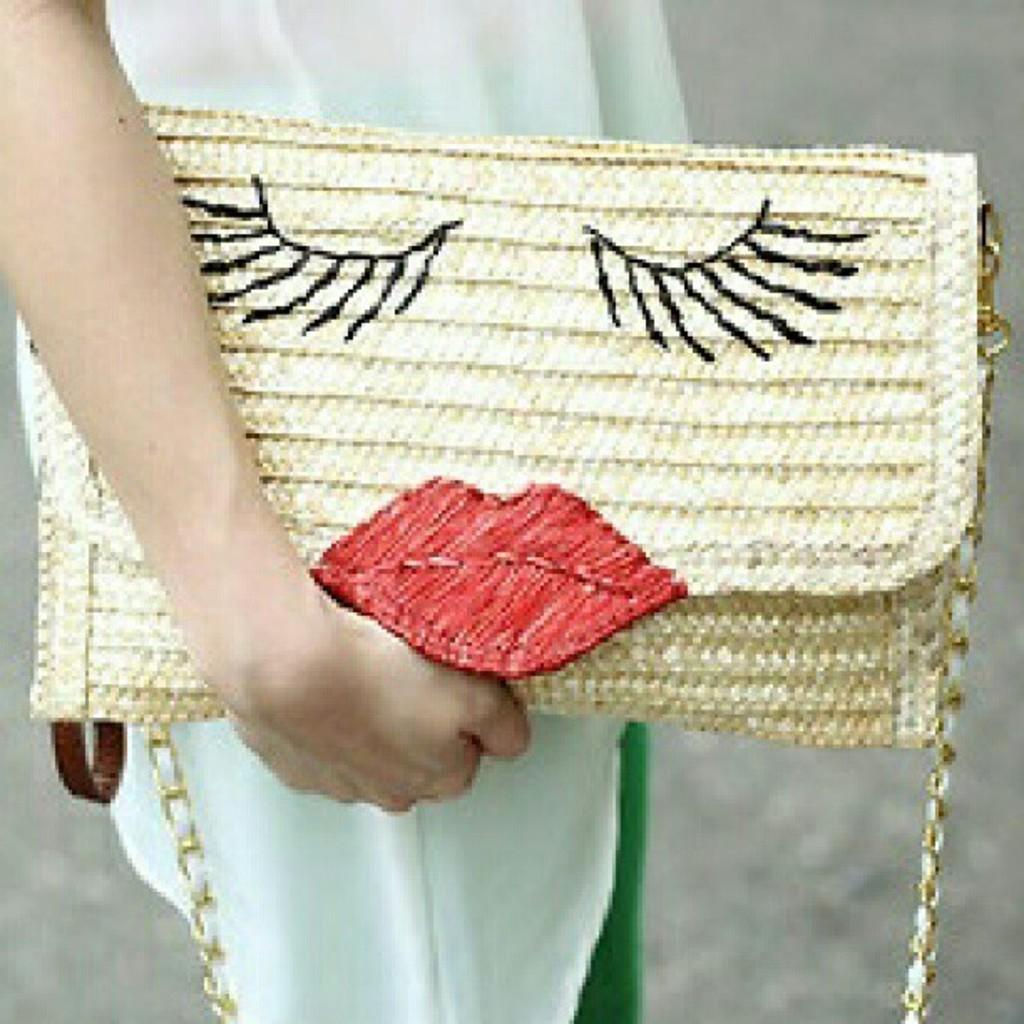What is present in the image that can be used to carry items? There is a bag in the image that can be used to carry items. What colors are visible on the bag? The bag is white and yellow in color. What additional detail can be observed on the bag? There is a red color object on the bag. Who is holding the bag in the image? There is a person holding a bag in the image. How many dolls are sitting on the hydrant in the image? There are no dolls or hydrants present in the image. What type of roll is being used to carry the bag in the image? There is no roll visible in the image; the person is holding the bag. 